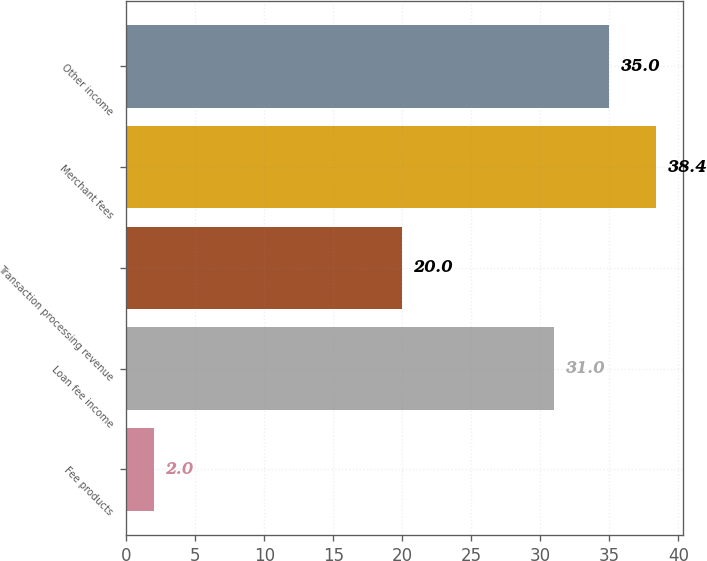Convert chart. <chart><loc_0><loc_0><loc_500><loc_500><bar_chart><fcel>Fee products<fcel>Loan fee income<fcel>Transaction processing revenue<fcel>Merchant fees<fcel>Other income<nl><fcel>2<fcel>31<fcel>20<fcel>38.4<fcel>35<nl></chart> 